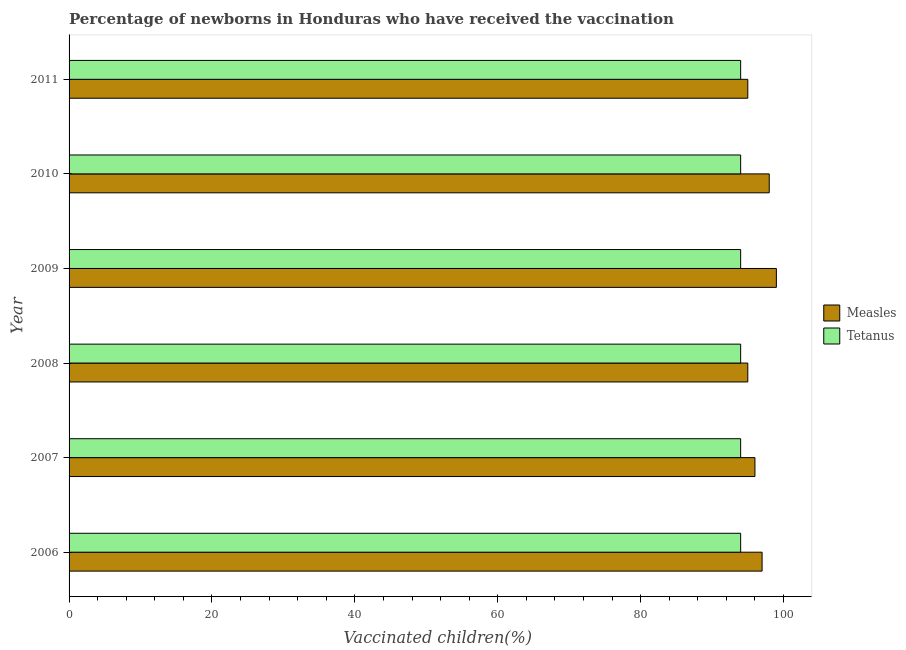How many different coloured bars are there?
Provide a succinct answer. 2. How many groups of bars are there?
Your response must be concise. 6. What is the label of the 5th group of bars from the top?
Offer a terse response. 2007. What is the percentage of newborns who received vaccination for measles in 2009?
Provide a short and direct response. 99. Across all years, what is the maximum percentage of newborns who received vaccination for tetanus?
Ensure brevity in your answer.  94. Across all years, what is the minimum percentage of newborns who received vaccination for measles?
Provide a short and direct response. 95. In which year was the percentage of newborns who received vaccination for tetanus minimum?
Offer a terse response. 2006. What is the total percentage of newborns who received vaccination for tetanus in the graph?
Offer a terse response. 564. What is the difference between the percentage of newborns who received vaccination for measles in 2008 and that in 2010?
Provide a succinct answer. -3. What is the difference between the percentage of newborns who received vaccination for tetanus in 2009 and the percentage of newborns who received vaccination for measles in 2010?
Ensure brevity in your answer.  -4. What is the average percentage of newborns who received vaccination for measles per year?
Provide a short and direct response. 96.67. In the year 2008, what is the difference between the percentage of newborns who received vaccination for tetanus and percentage of newborns who received vaccination for measles?
Offer a very short reply. -1. In how many years, is the percentage of newborns who received vaccination for tetanus greater than 52 %?
Give a very brief answer. 6. Is the difference between the percentage of newborns who received vaccination for measles in 2006 and 2011 greater than the difference between the percentage of newborns who received vaccination for tetanus in 2006 and 2011?
Your response must be concise. Yes. What is the difference between the highest and the second highest percentage of newborns who received vaccination for measles?
Offer a terse response. 1. What is the difference between the highest and the lowest percentage of newborns who received vaccination for measles?
Offer a terse response. 4. In how many years, is the percentage of newborns who received vaccination for tetanus greater than the average percentage of newborns who received vaccination for tetanus taken over all years?
Keep it short and to the point. 0. What does the 2nd bar from the top in 2007 represents?
Provide a succinct answer. Measles. What does the 2nd bar from the bottom in 2006 represents?
Ensure brevity in your answer.  Tetanus. How many bars are there?
Provide a succinct answer. 12. Are the values on the major ticks of X-axis written in scientific E-notation?
Provide a short and direct response. No. Does the graph contain grids?
Keep it short and to the point. No. How many legend labels are there?
Ensure brevity in your answer.  2. What is the title of the graph?
Your answer should be very brief. Percentage of newborns in Honduras who have received the vaccination. What is the label or title of the X-axis?
Make the answer very short. Vaccinated children(%)
. What is the Vaccinated children(%)
 in Measles in 2006?
Your answer should be compact. 97. What is the Vaccinated children(%)
 in Tetanus in 2006?
Your answer should be very brief. 94. What is the Vaccinated children(%)
 of Measles in 2007?
Provide a succinct answer. 96. What is the Vaccinated children(%)
 in Tetanus in 2007?
Ensure brevity in your answer.  94. What is the Vaccinated children(%)
 of Tetanus in 2008?
Your answer should be compact. 94. What is the Vaccinated children(%)
 of Tetanus in 2009?
Your response must be concise. 94. What is the Vaccinated children(%)
 of Measles in 2010?
Make the answer very short. 98. What is the Vaccinated children(%)
 of Tetanus in 2010?
Your answer should be very brief. 94. What is the Vaccinated children(%)
 in Tetanus in 2011?
Offer a very short reply. 94. Across all years, what is the maximum Vaccinated children(%)
 in Tetanus?
Give a very brief answer. 94. Across all years, what is the minimum Vaccinated children(%)
 in Tetanus?
Your answer should be very brief. 94. What is the total Vaccinated children(%)
 of Measles in the graph?
Provide a succinct answer. 580. What is the total Vaccinated children(%)
 of Tetanus in the graph?
Your response must be concise. 564. What is the difference between the Vaccinated children(%)
 of Tetanus in 2006 and that in 2007?
Your answer should be very brief. 0. What is the difference between the Vaccinated children(%)
 in Tetanus in 2006 and that in 2008?
Your response must be concise. 0. What is the difference between the Vaccinated children(%)
 of Measles in 2006 and that in 2009?
Your answer should be compact. -2. What is the difference between the Vaccinated children(%)
 in Tetanus in 2006 and that in 2009?
Make the answer very short. 0. What is the difference between the Vaccinated children(%)
 in Measles in 2006 and that in 2010?
Your response must be concise. -1. What is the difference between the Vaccinated children(%)
 in Measles in 2007 and that in 2008?
Keep it short and to the point. 1. What is the difference between the Vaccinated children(%)
 in Tetanus in 2007 and that in 2008?
Your answer should be compact. 0. What is the difference between the Vaccinated children(%)
 of Measles in 2007 and that in 2009?
Offer a very short reply. -3. What is the difference between the Vaccinated children(%)
 of Tetanus in 2007 and that in 2009?
Offer a very short reply. 0. What is the difference between the Vaccinated children(%)
 of Measles in 2007 and that in 2010?
Make the answer very short. -2. What is the difference between the Vaccinated children(%)
 of Measles in 2007 and that in 2011?
Keep it short and to the point. 1. What is the difference between the Vaccinated children(%)
 in Measles in 2008 and that in 2009?
Give a very brief answer. -4. What is the difference between the Vaccinated children(%)
 of Tetanus in 2008 and that in 2009?
Offer a terse response. 0. What is the difference between the Vaccinated children(%)
 in Measles in 2008 and that in 2010?
Your answer should be very brief. -3. What is the difference between the Vaccinated children(%)
 of Tetanus in 2008 and that in 2010?
Make the answer very short. 0. What is the difference between the Vaccinated children(%)
 in Measles in 2008 and that in 2011?
Offer a terse response. 0. What is the difference between the Vaccinated children(%)
 of Tetanus in 2008 and that in 2011?
Offer a terse response. 0. What is the difference between the Vaccinated children(%)
 of Measles in 2009 and that in 2010?
Provide a short and direct response. 1. What is the difference between the Vaccinated children(%)
 of Tetanus in 2009 and that in 2010?
Your answer should be very brief. 0. What is the difference between the Vaccinated children(%)
 of Measles in 2006 and the Vaccinated children(%)
 of Tetanus in 2010?
Make the answer very short. 3. What is the difference between the Vaccinated children(%)
 in Measles in 2008 and the Vaccinated children(%)
 in Tetanus in 2009?
Your response must be concise. 1. What is the difference between the Vaccinated children(%)
 of Measles in 2008 and the Vaccinated children(%)
 of Tetanus in 2010?
Offer a very short reply. 1. What is the difference between the Vaccinated children(%)
 in Measles in 2009 and the Vaccinated children(%)
 in Tetanus in 2010?
Give a very brief answer. 5. What is the difference between the Vaccinated children(%)
 in Measles in 2010 and the Vaccinated children(%)
 in Tetanus in 2011?
Ensure brevity in your answer.  4. What is the average Vaccinated children(%)
 in Measles per year?
Make the answer very short. 96.67. What is the average Vaccinated children(%)
 in Tetanus per year?
Your response must be concise. 94. In the year 2009, what is the difference between the Vaccinated children(%)
 of Measles and Vaccinated children(%)
 of Tetanus?
Make the answer very short. 5. In the year 2011, what is the difference between the Vaccinated children(%)
 in Measles and Vaccinated children(%)
 in Tetanus?
Provide a short and direct response. 1. What is the ratio of the Vaccinated children(%)
 of Measles in 2006 to that in 2007?
Provide a succinct answer. 1.01. What is the ratio of the Vaccinated children(%)
 of Tetanus in 2006 to that in 2007?
Your answer should be very brief. 1. What is the ratio of the Vaccinated children(%)
 of Measles in 2006 to that in 2008?
Make the answer very short. 1.02. What is the ratio of the Vaccinated children(%)
 in Tetanus in 2006 to that in 2008?
Provide a succinct answer. 1. What is the ratio of the Vaccinated children(%)
 of Measles in 2006 to that in 2009?
Offer a very short reply. 0.98. What is the ratio of the Vaccinated children(%)
 of Measles in 2006 to that in 2010?
Your answer should be very brief. 0.99. What is the ratio of the Vaccinated children(%)
 of Measles in 2006 to that in 2011?
Provide a succinct answer. 1.02. What is the ratio of the Vaccinated children(%)
 in Tetanus in 2006 to that in 2011?
Keep it short and to the point. 1. What is the ratio of the Vaccinated children(%)
 of Measles in 2007 to that in 2008?
Ensure brevity in your answer.  1.01. What is the ratio of the Vaccinated children(%)
 in Tetanus in 2007 to that in 2008?
Your answer should be very brief. 1. What is the ratio of the Vaccinated children(%)
 in Measles in 2007 to that in 2009?
Offer a terse response. 0.97. What is the ratio of the Vaccinated children(%)
 in Tetanus in 2007 to that in 2009?
Offer a terse response. 1. What is the ratio of the Vaccinated children(%)
 of Measles in 2007 to that in 2010?
Your response must be concise. 0.98. What is the ratio of the Vaccinated children(%)
 in Tetanus in 2007 to that in 2010?
Offer a terse response. 1. What is the ratio of the Vaccinated children(%)
 in Measles in 2007 to that in 2011?
Your response must be concise. 1.01. What is the ratio of the Vaccinated children(%)
 in Tetanus in 2007 to that in 2011?
Your answer should be compact. 1. What is the ratio of the Vaccinated children(%)
 of Measles in 2008 to that in 2009?
Make the answer very short. 0.96. What is the ratio of the Vaccinated children(%)
 of Tetanus in 2008 to that in 2009?
Provide a succinct answer. 1. What is the ratio of the Vaccinated children(%)
 in Measles in 2008 to that in 2010?
Provide a short and direct response. 0.97. What is the ratio of the Vaccinated children(%)
 in Measles in 2008 to that in 2011?
Offer a terse response. 1. What is the ratio of the Vaccinated children(%)
 in Tetanus in 2008 to that in 2011?
Provide a short and direct response. 1. What is the ratio of the Vaccinated children(%)
 in Measles in 2009 to that in 2010?
Provide a short and direct response. 1.01. What is the ratio of the Vaccinated children(%)
 of Measles in 2009 to that in 2011?
Provide a short and direct response. 1.04. What is the ratio of the Vaccinated children(%)
 of Measles in 2010 to that in 2011?
Offer a very short reply. 1.03. What is the ratio of the Vaccinated children(%)
 in Tetanus in 2010 to that in 2011?
Offer a very short reply. 1. What is the difference between the highest and the second highest Vaccinated children(%)
 in Measles?
Your answer should be compact. 1. What is the difference between the highest and the second highest Vaccinated children(%)
 in Tetanus?
Your answer should be very brief. 0. What is the difference between the highest and the lowest Vaccinated children(%)
 of Measles?
Provide a short and direct response. 4. 